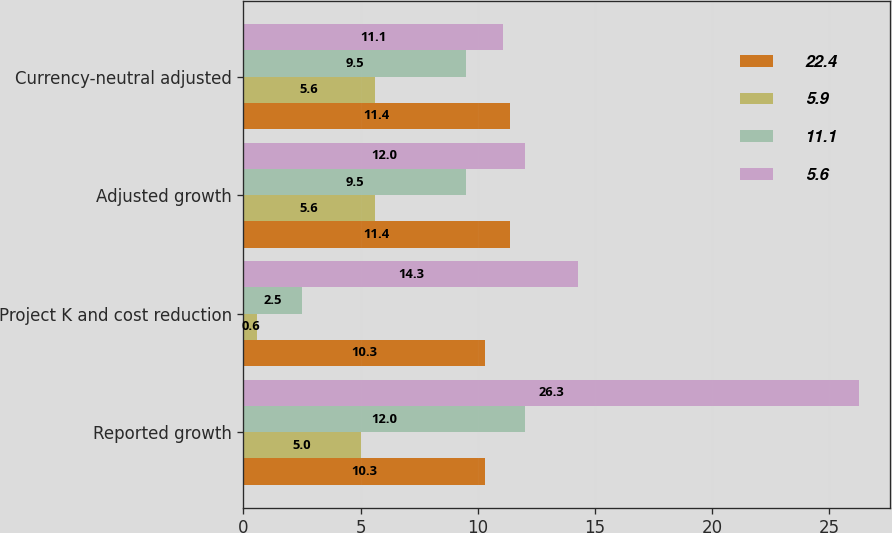Convert chart to OTSL. <chart><loc_0><loc_0><loc_500><loc_500><stacked_bar_chart><ecel><fcel>Reported growth<fcel>Project K and cost reduction<fcel>Adjusted growth<fcel>Currency-neutral adjusted<nl><fcel>22.4<fcel>10.3<fcel>10.3<fcel>11.4<fcel>11.4<nl><fcel>5.9<fcel>5<fcel>0.6<fcel>5.6<fcel>5.6<nl><fcel>11.1<fcel>12<fcel>2.5<fcel>9.5<fcel>9.5<nl><fcel>5.6<fcel>26.3<fcel>14.3<fcel>12<fcel>11.1<nl></chart> 